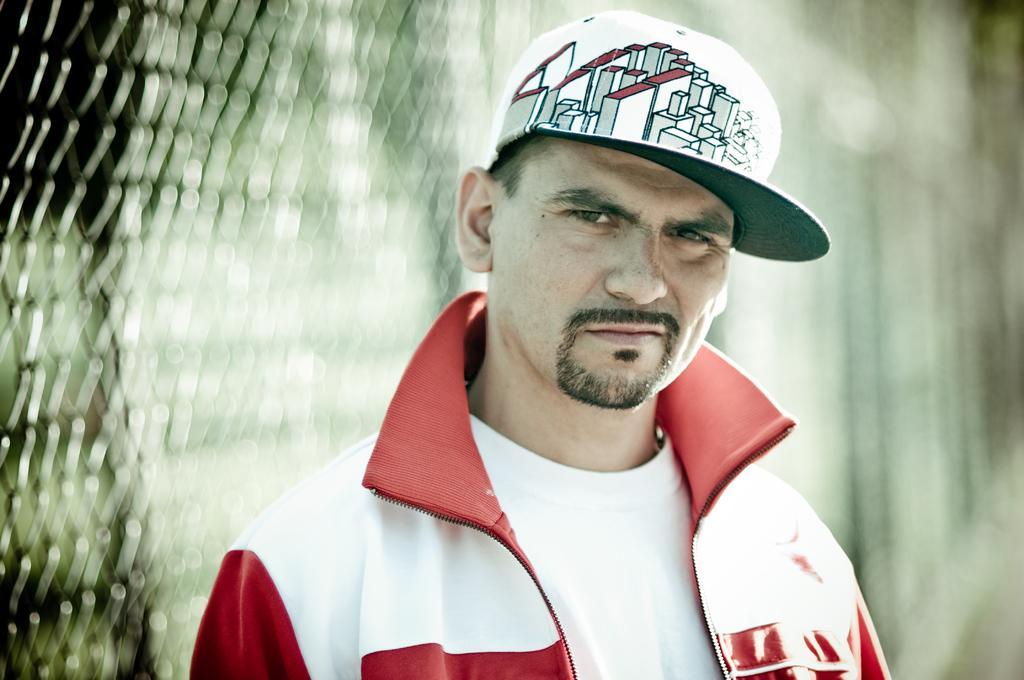Could you give a brief overview of what you see in this image? In this image I can see person standing and wearing red and white color jacket and white cap. Background is blurred. 